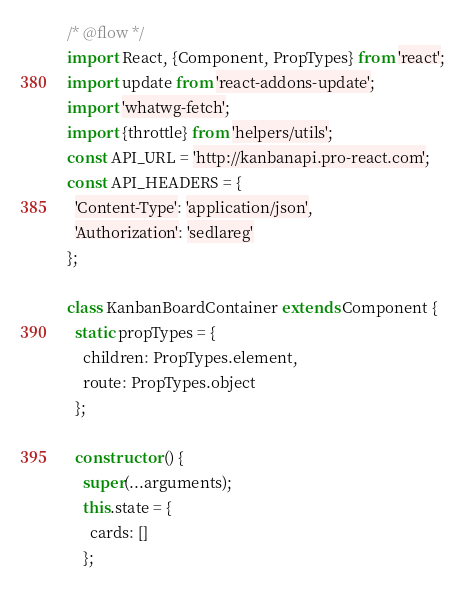<code> <loc_0><loc_0><loc_500><loc_500><_JavaScript_>/* @flow */
import React, {Component, PropTypes} from 'react';
import update from 'react-addons-update';
import 'whatwg-fetch';
import {throttle} from 'helpers/utils';
const API_URL = 'http://kanbanapi.pro-react.com';
const API_HEADERS = {
  'Content-Type': 'application/json',
  'Authorization': 'sedlareg'
};

class KanbanBoardContainer extends Component {
  static propTypes = {
    children: PropTypes.element,
    route: PropTypes.object
  };

  constructor () {
    super(...arguments);
    this.state = {
      cards: []
    };
</code> 